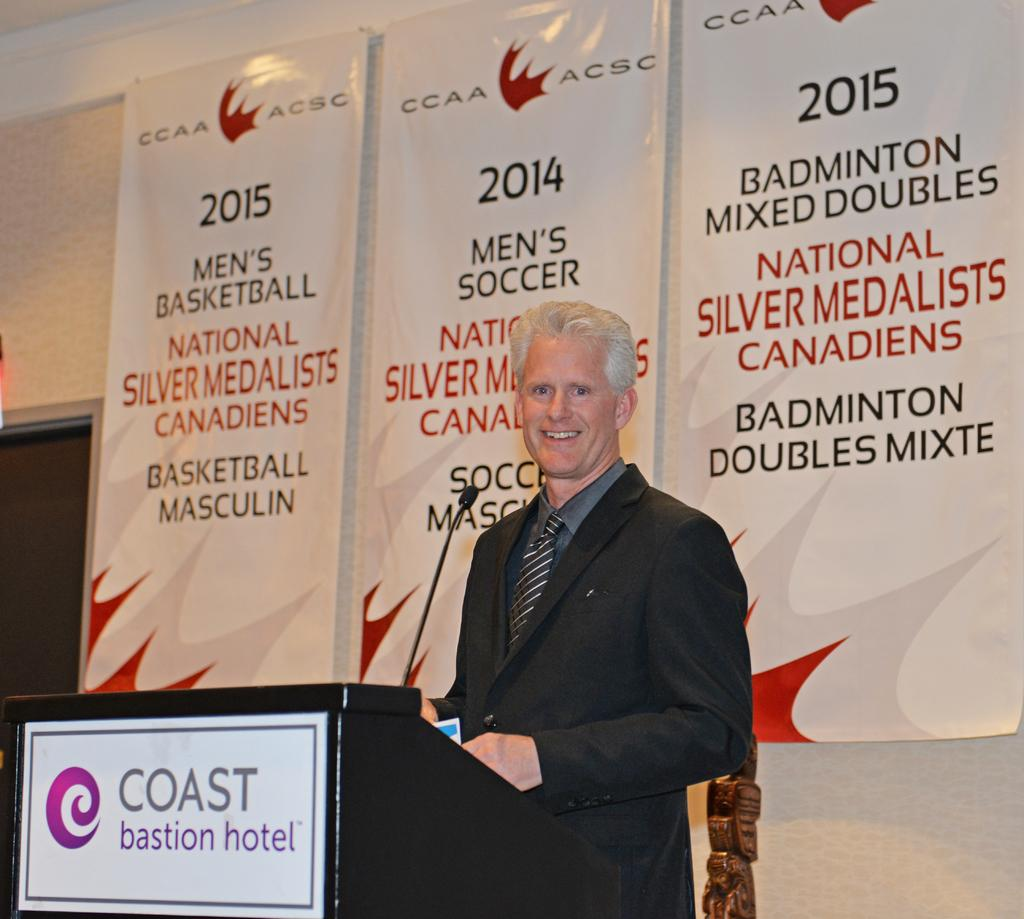Who is the main subject in the image? There is a man in the image. Where is the man positioned in the image? The man is standing in the center of the image. What is in front of the man? There is a desk and a microphone (mic) in front of the man. What can be seen in the background of the image? There are posters in the background of the image. What religious symbol is hanging from the ceiling in the image? There is no religious symbol hanging from the ceiling in the image. Is the man in the image feeling any shame? The image does not provide any information about the man's emotions, including shame. 